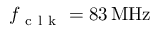<formula> <loc_0><loc_0><loc_500><loc_500>f _ { c l k } = 8 \, M H z</formula> 